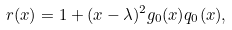<formula> <loc_0><loc_0><loc_500><loc_500>r ( x ) = 1 + ( x - \lambda ) ^ { 2 } g _ { 0 } ( x ) q _ { 0 } ( x ) ,</formula> 